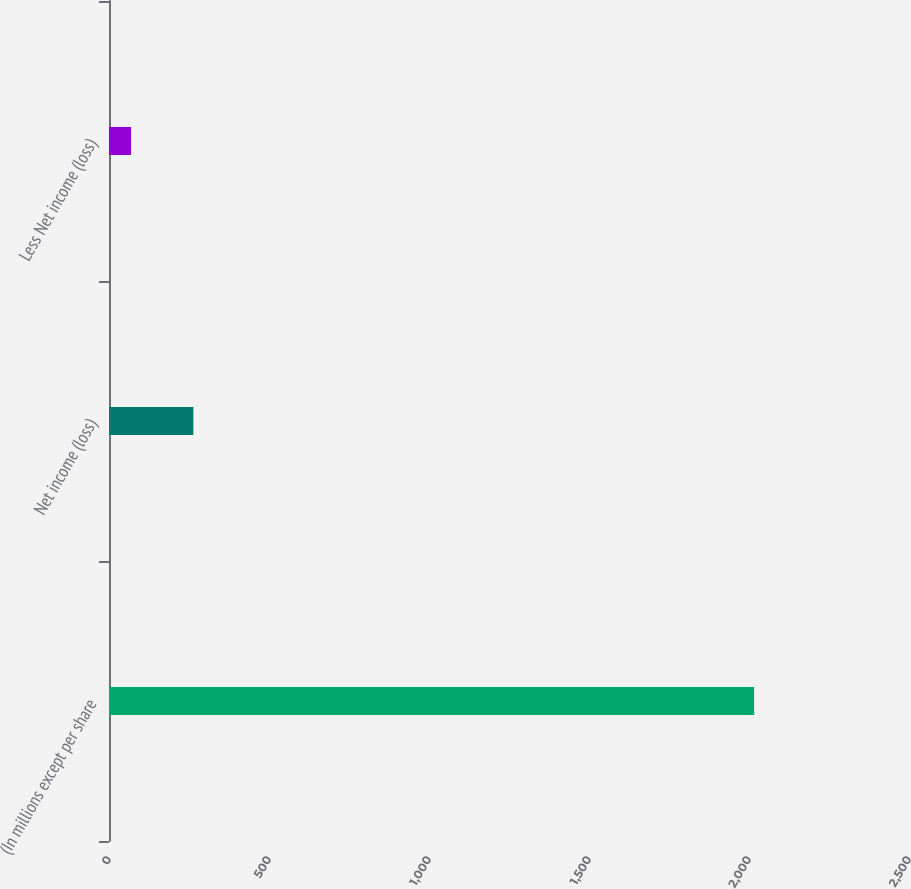Convert chart. <chart><loc_0><loc_0><loc_500><loc_500><bar_chart><fcel>(In millions except per share<fcel>Net income (loss)<fcel>Less Net income (loss)<nl><fcel>2016<fcel>263.7<fcel>69<nl></chart> 